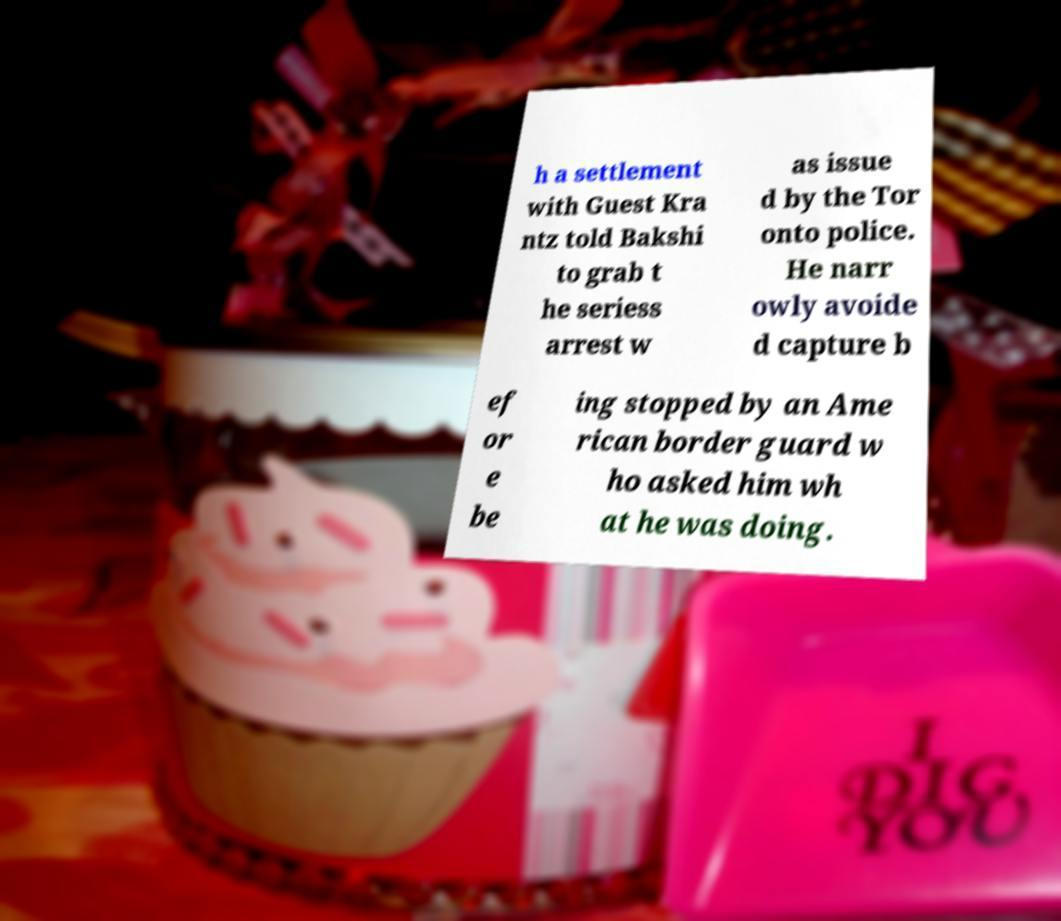Could you assist in decoding the text presented in this image and type it out clearly? h a settlement with Guest Kra ntz told Bakshi to grab t he seriess arrest w as issue d by the Tor onto police. He narr owly avoide d capture b ef or e be ing stopped by an Ame rican border guard w ho asked him wh at he was doing. 